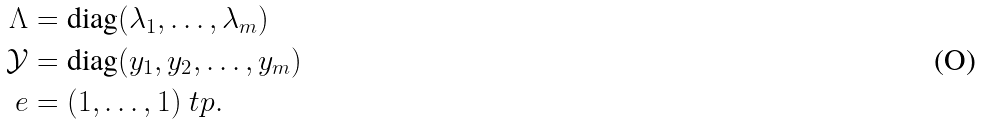Convert formula to latex. <formula><loc_0><loc_0><loc_500><loc_500>\Lambda & = \text {diag} ( \lambda _ { 1 } , \dots , \lambda _ { m } ) \\ \mathcal { Y } & = \text {diag} ( y _ { 1 } , y _ { 2 } , \dots , y _ { m } ) \\ e & = ( 1 , \dots , 1 ) ^ { \ } t p .</formula> 